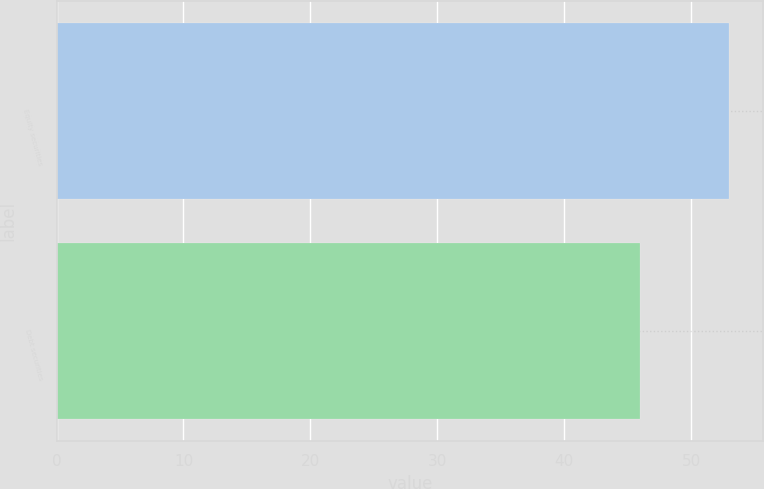<chart> <loc_0><loc_0><loc_500><loc_500><bar_chart><fcel>Equity securities<fcel>Debt securities<nl><fcel>53<fcel>46<nl></chart> 